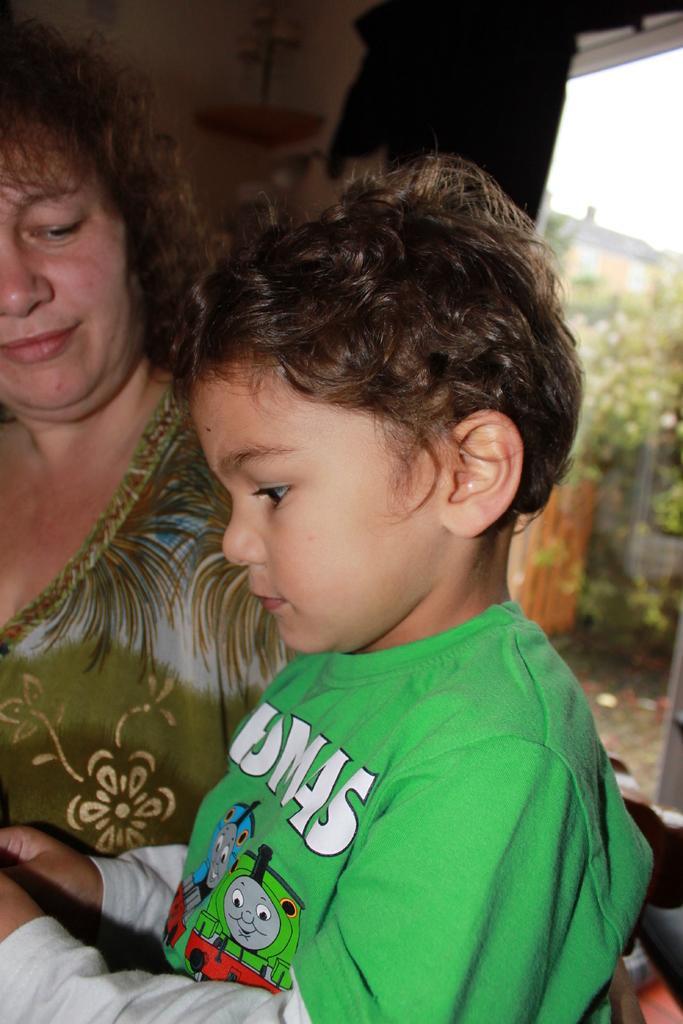How would you summarize this image in a sentence or two? In the picture there is a boy and behind the boy there is a woman, she is looking at the boy. In the background there is a window and behind the window there are few trees. 